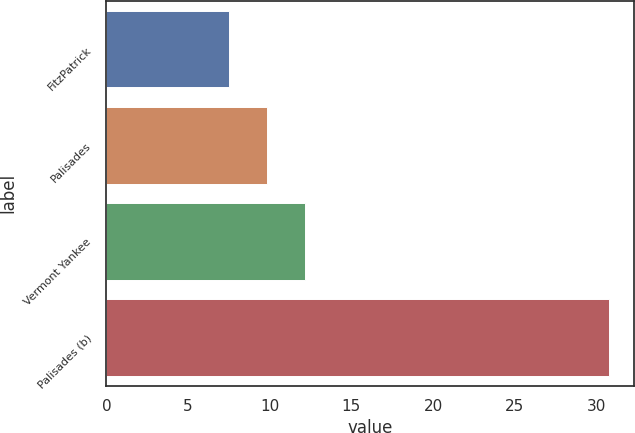<chart> <loc_0><loc_0><loc_500><loc_500><bar_chart><fcel>FitzPatrick<fcel>Palisades<fcel>Vermont Yankee<fcel>Palisades (b)<nl><fcel>7.5<fcel>9.83<fcel>12.16<fcel>30.8<nl></chart> 